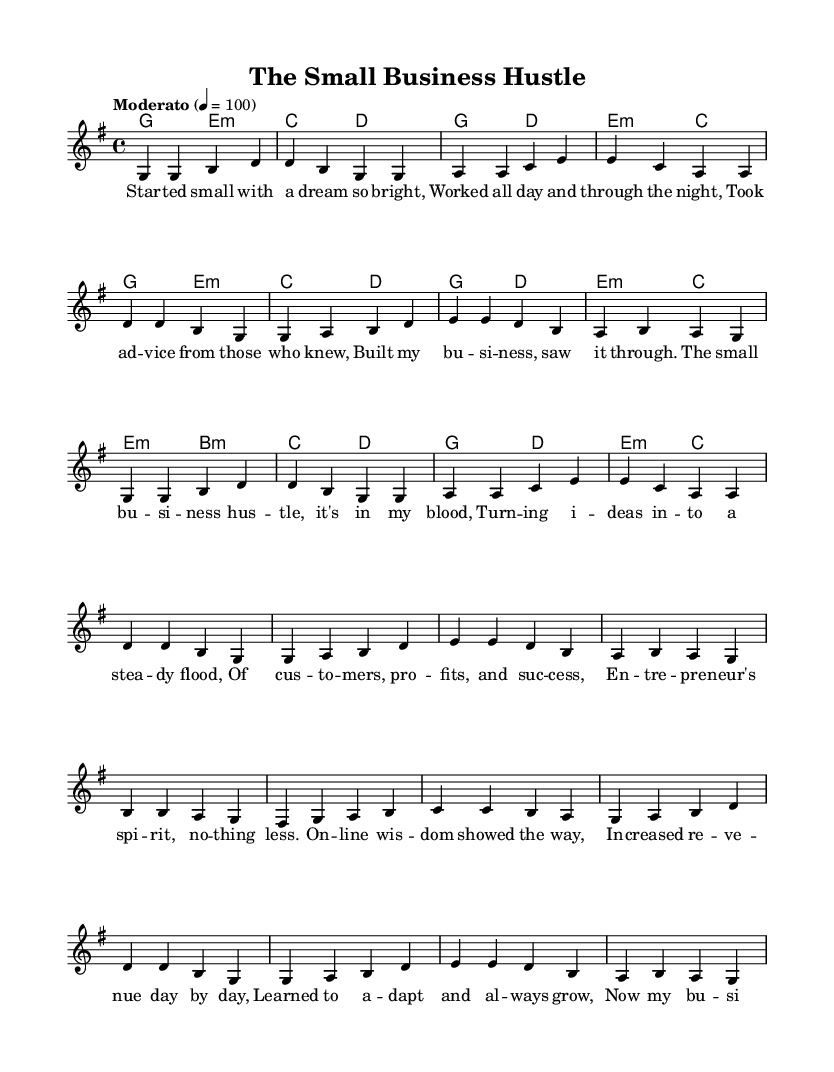What is the key signature of this music? The key signature consists of one sharp (F#), indicating it is in G major. You can determine this by looking at the global settings where it specifies \key g \major.
Answer: G major What is the time signature of this music? The time signature is found in the global section, where it specifies \time 4/4. This indicates that there are four beats in each measure, and the quarter note receives one beat.
Answer: 4/4 What is the tempo marking of this piece? The tempo marking is indicated as "Moderato" with a metronome marking of 100, which is typically a moderate speed for performance. This is found in the global settings as well.
Answer: Moderato 4 = 100 How many verses are there in this piece? To find the number of verses, examine the structure of the lyrics. The lyrics include two distinct sections labeled as "Verse," which occurs twice, meaning there are two verses overall.
Answer: 2 What element in the lyrics emphasizes entrepreneurship? The chorus contains the phrase "entrepreneur's spirit", which directly relates to entrepreneurship and business success. This shows the overall theme and message of the song.
Answer: entrepreneur's spirit What notes are primarily used in the bridge section? The bridge utilizes the notes b, a, g, fis, c, and d. These notes can be found in the melody section of the code under the bridge lyrics section. The analysis of the melody shows the specific notes played during the bridge.
Answer: b, a, g, fis, c, d What is the first word of the song? The first word of the song is "Started," as seen in the first lyric section where it begins the narrative of the small business venture. The lyrics explicitly start with this word in the first verse.
Answer: Started 